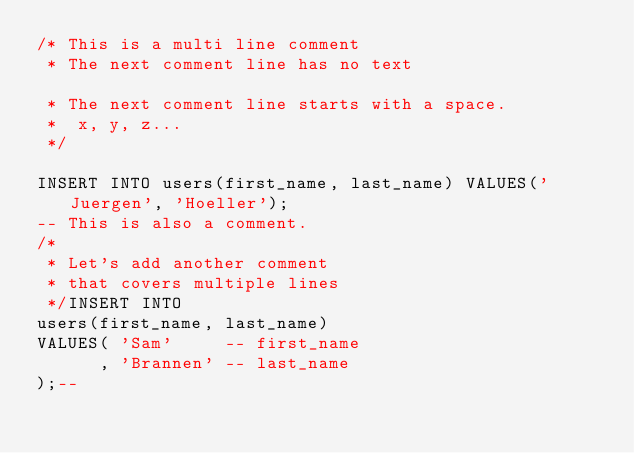Convert code to text. <code><loc_0><loc_0><loc_500><loc_500><_SQL_>/* This is a multi line comment
 * The next comment line has no text 

 * The next comment line starts with a space.
 *  x, y, z... 
 */

INSERT INTO users(first_name, last_name) VALUES('Juergen', 'Hoeller');
-- This is also a comment.
/* 
 * Let's add another comment
 * that covers multiple lines
 */INSERT INTO
users(first_name, last_name)
VALUES( 'Sam'     -- first_name
      , 'Brannen' -- last_name
);--</code> 